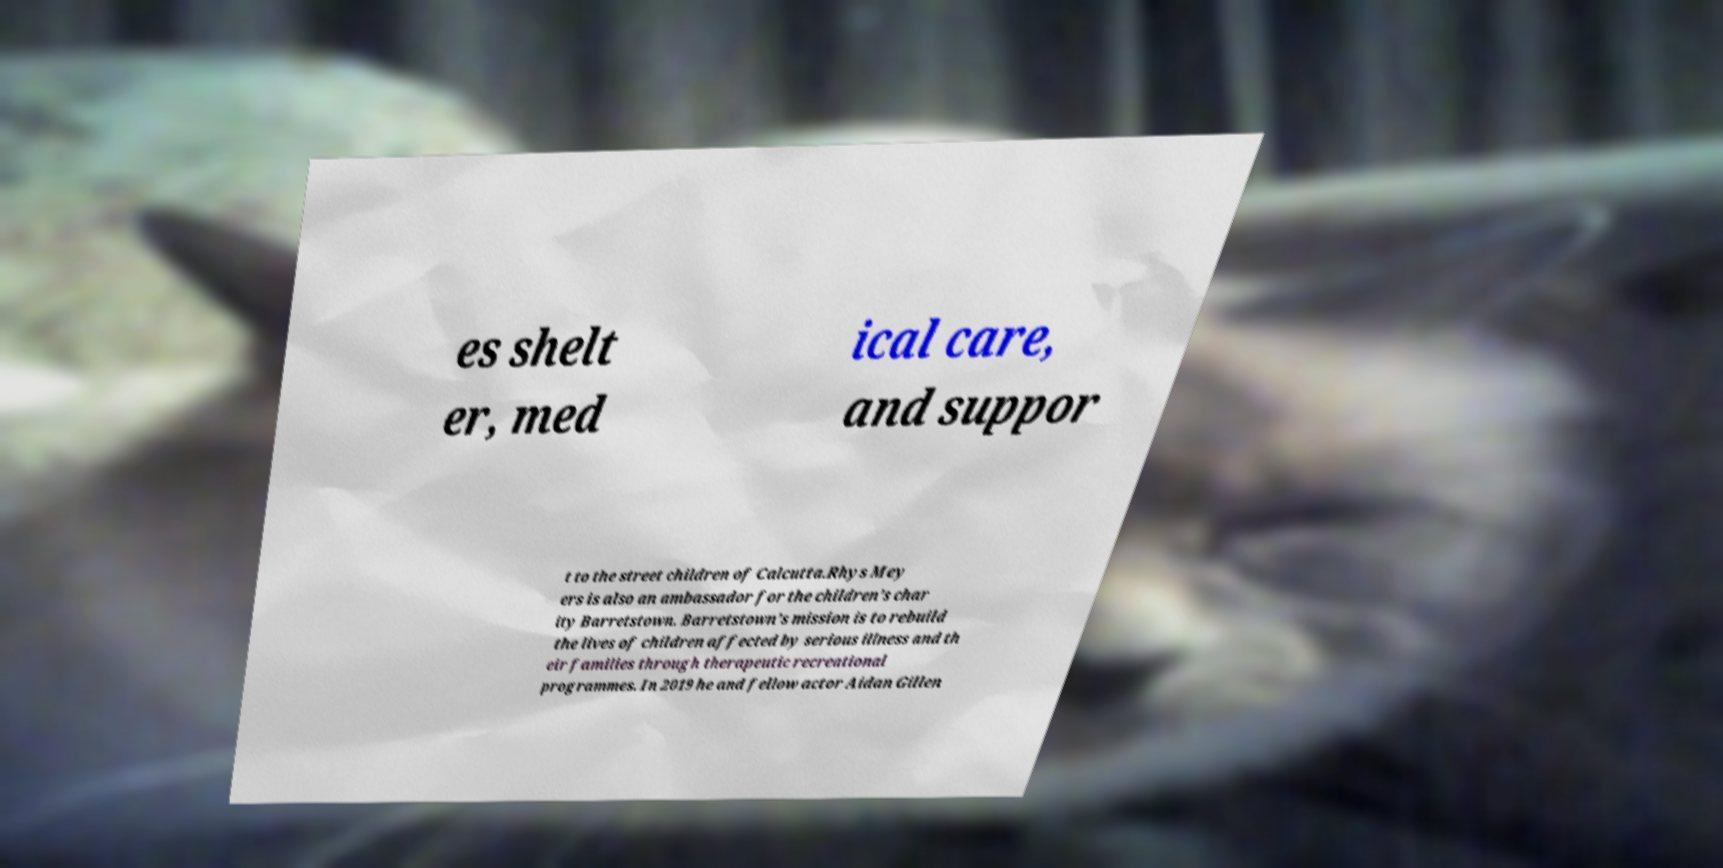Can you accurately transcribe the text from the provided image for me? es shelt er, med ical care, and suppor t to the street children of Calcutta.Rhys Mey ers is also an ambassador for the children’s char ity Barretstown. Barretstown’s mission is to rebuild the lives of children affected by serious illness and th eir families through therapeutic recreational programmes. In 2019 he and fellow actor Aidan Gillen 